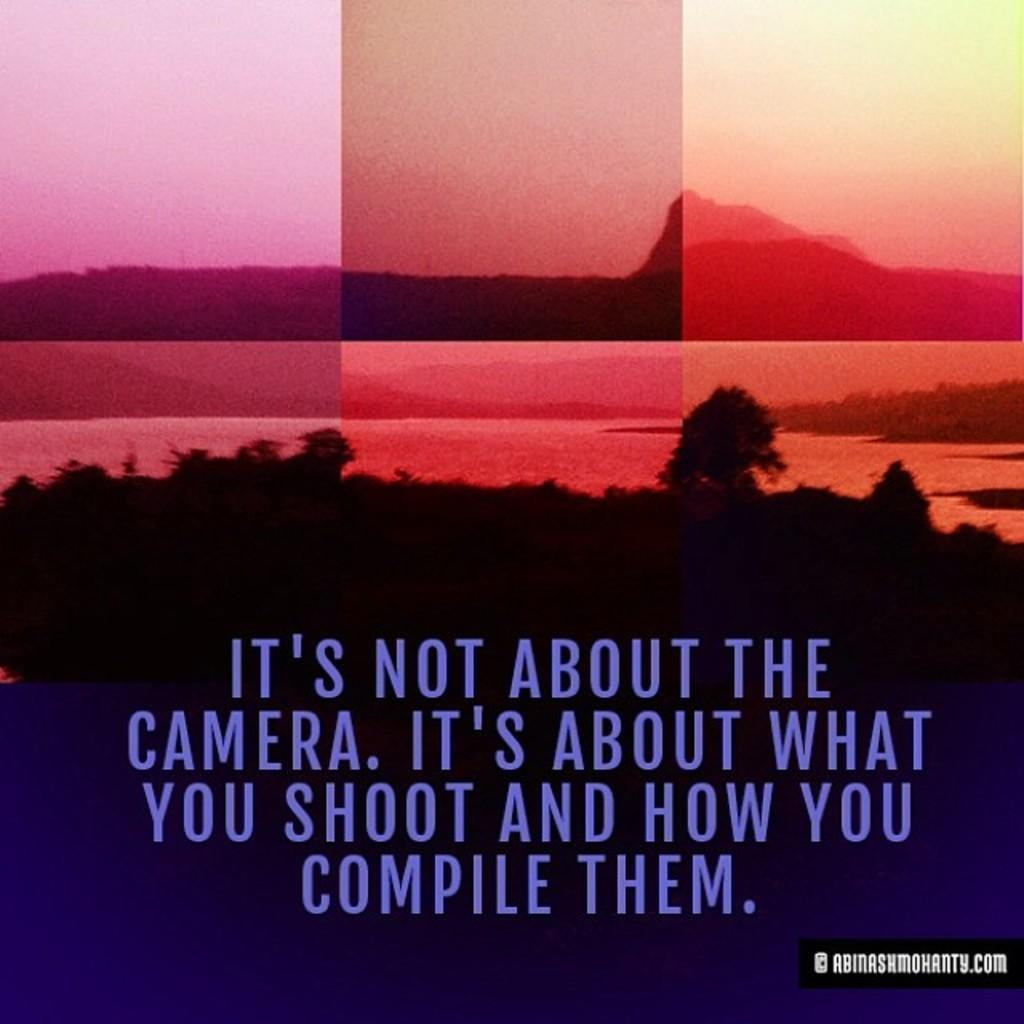<image>
Present a compact description of the photo's key features. Background of a beach with a saying under it that says "It's not about the camera". 